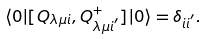<formula> <loc_0><loc_0><loc_500><loc_500>\langle 0 | [ Q _ { \lambda \mu i } , Q _ { \lambda \mu i ^ { ^ { \prime } } } ^ { + } ] | 0 \rangle = \delta _ { i i ^ { ^ { \prime } } } .</formula> 